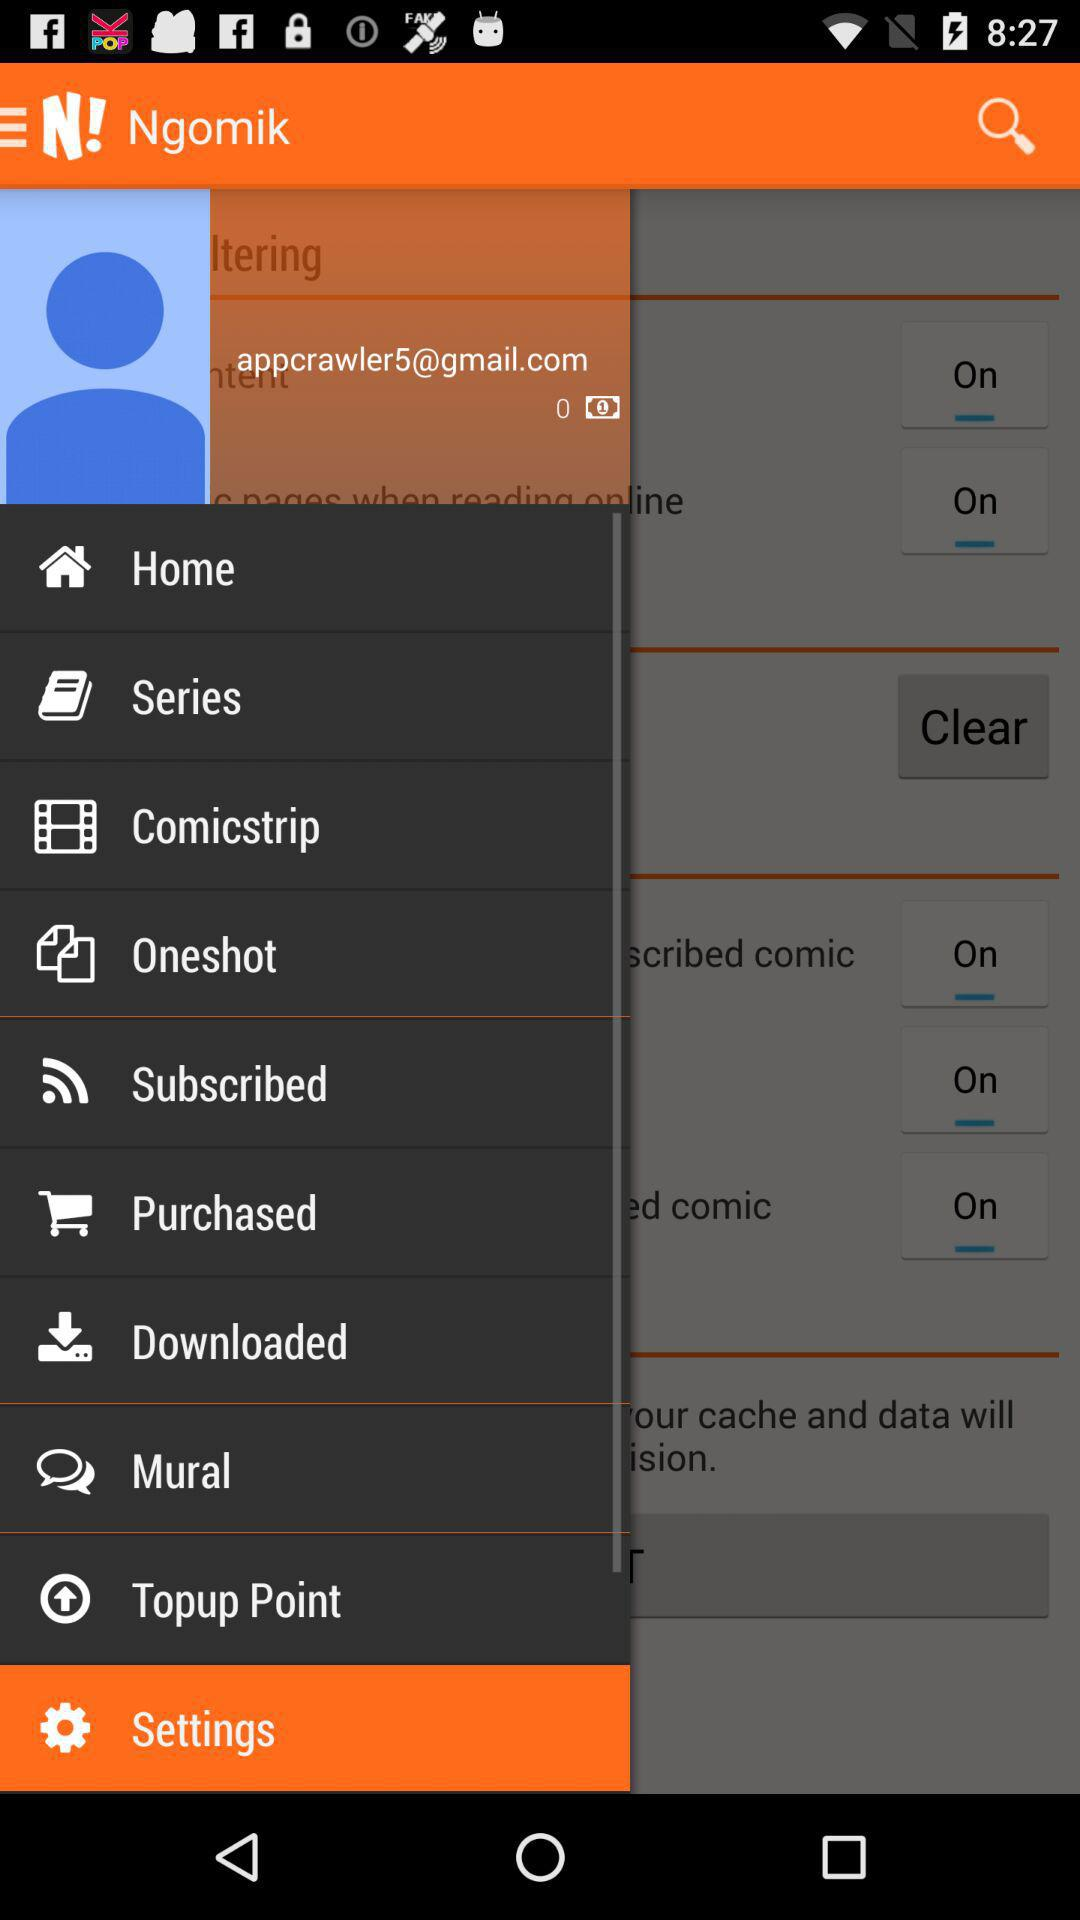What is the email address? The email address is "appcrawler5@gmail.com". 